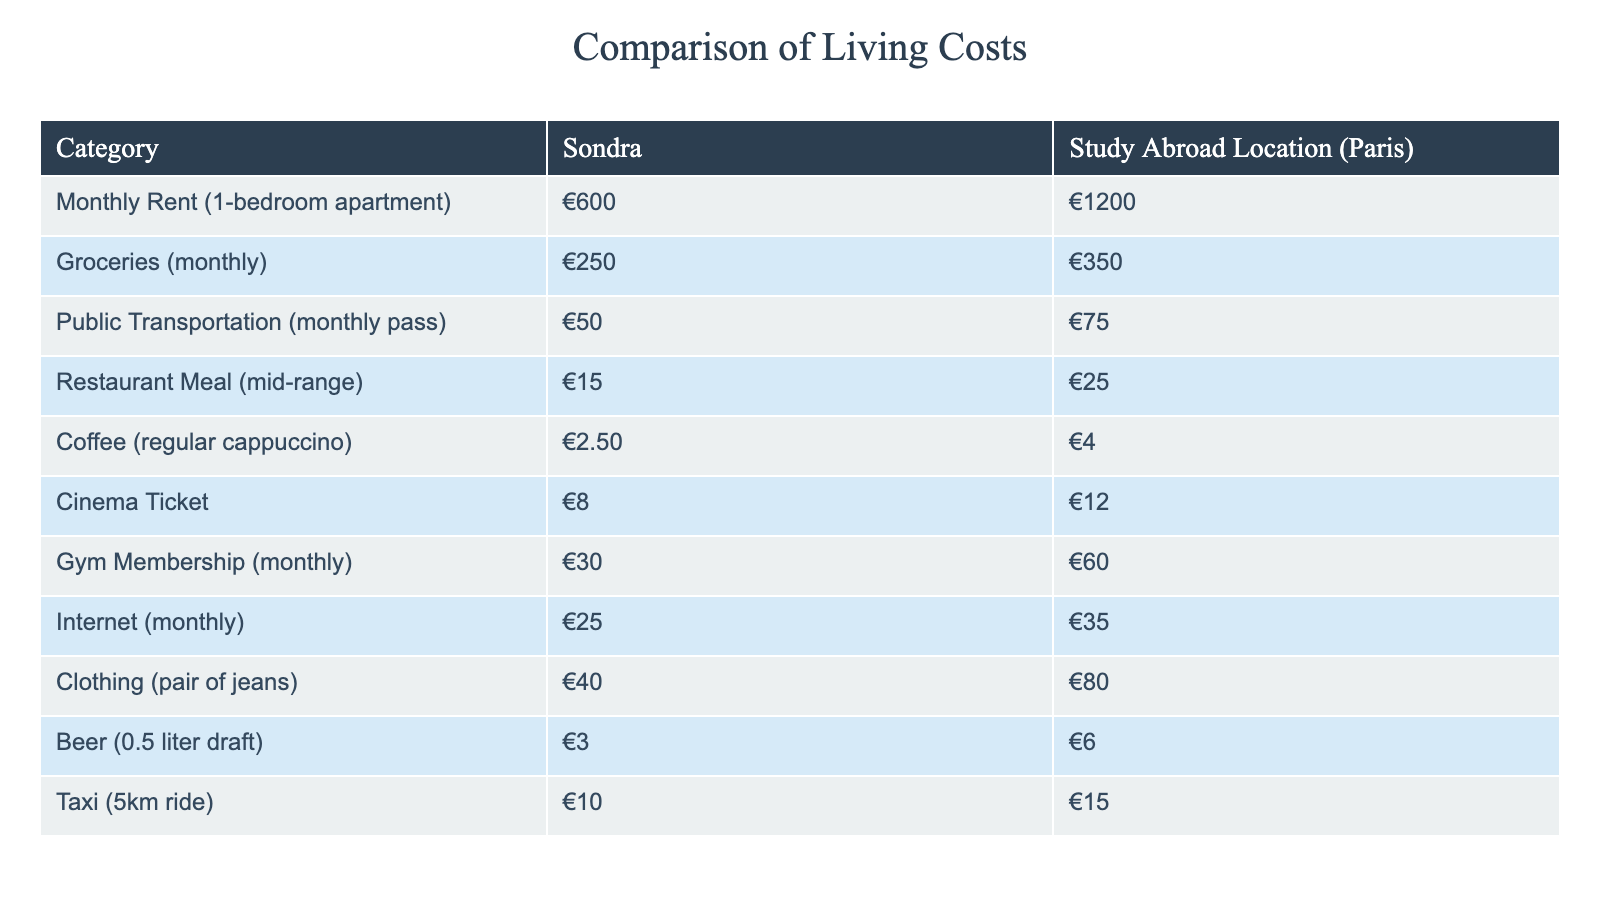What is the monthly rent for a 1-bedroom apartment in Sondra? The table shows that the monthly rent for a 1-bedroom apartment in Sondra is €600.
Answer: €600 What is the price of a cinema ticket in the study abroad location? According to the table, a cinema ticket in Paris costs €12.
Answer: €12 Is the cost of groceries in Sondra lower than in the study abroad location? The table reveals that groceries in Sondra are €250, whereas in Paris they are €350. Hence, groceries in Sondra are lower.
Answer: Yes What is the total cost of public transportation and internet in Sondra? To find the total, we add the cost of public transportation (€50) to the internet (€25). So, €50 + €25 = €75.
Answer: €75 Which category has the highest cost difference between Sondra and the study abroad location? Analyzing the data, the category with the highest cost difference is monthly rent, showing €1200 - €600 = €600 difference.
Answer: Monthly Rent What is the average cost of restaurant meals in both locations? The average cost would be calculated by adding the cost in Sondra (€15) to the cost in Paris (€25), yielding €40. Then, dividing by 2 gives €20 as the average.
Answer: €20 Is it more expensive to have a gym membership in Sondra compared to the study abroad location? The table indicates that a gym membership in Sondra costs €30 while in the study abroad location it's €60. Therefore, it's not more expensive in Sondra.
Answer: No What is the difference in cost for a taxi ride (5km) between the two locations? The taxi ride in Sondra is €10 and in Paris it is €15. The difference is €15 - €10 = €5.
Answer: €5 What is the total cost of one month of living in Sondra, considering rent, groceries, public transportation, and internet? To compute this, add the monthly rent (€600), groceries (€250), public transportation (€50), and internet (€25): €600 + €250 + €50 + €25 = €925 total.
Answer: €925 